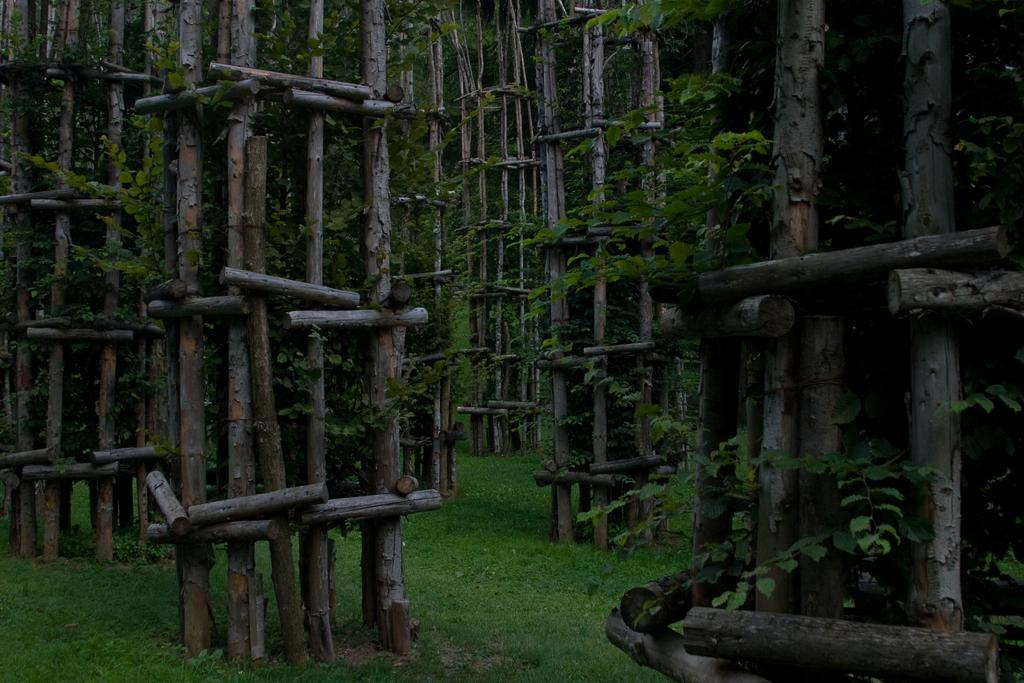What type of vegetation is predominant in the image? There are many bamboos in the image. Are there any other types of plants visible in the image? Yes, there are creepers in the image. What is the ground cover in the image? There is grass at the bottom of the image. What type of quartz can be seen in the image? There is no quartz present in the image. What is the slope of the terrain in the image? The image does not provide information about the slope of the terrain, as it only shows vegetation and ground cover. 